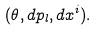Convert formula to latex. <formula><loc_0><loc_0><loc_500><loc_500>( \theta , d p _ { l } , d x ^ { i } ) .</formula> 